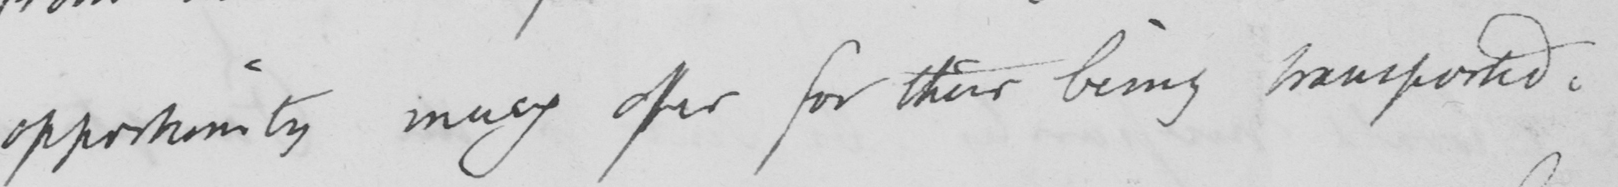Can you read and transcribe this handwriting? opportunity may offer for their being transported. 